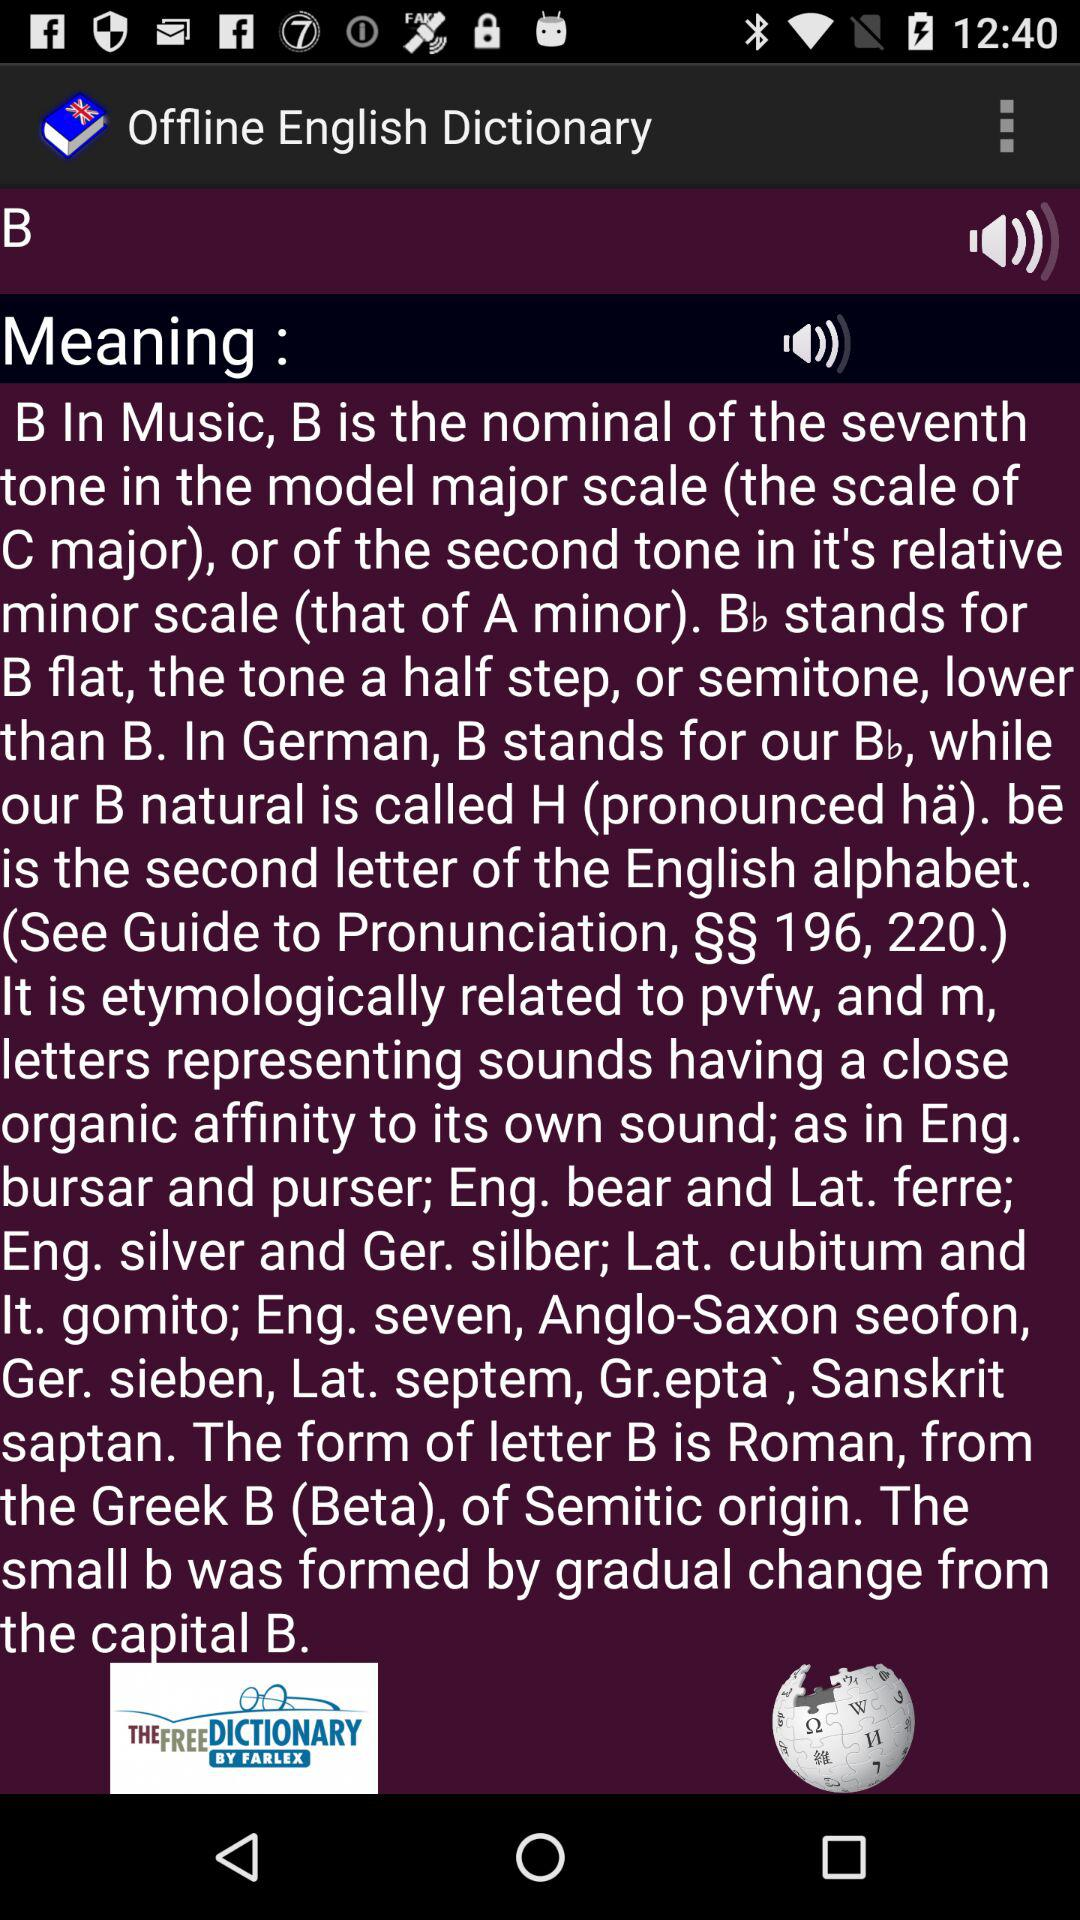What is the application name? The application name is "Offline English Dictionary". 